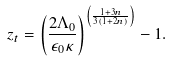<formula> <loc_0><loc_0><loc_500><loc_500>z _ { t } = \left ( \frac { 2 \Lambda _ { 0 } } { \epsilon _ { 0 } \kappa } \right ) ^ { \left ( \frac { 1 + 3 n } { 3 ( 1 + 2 n ) } \right ) } - 1 .</formula> 